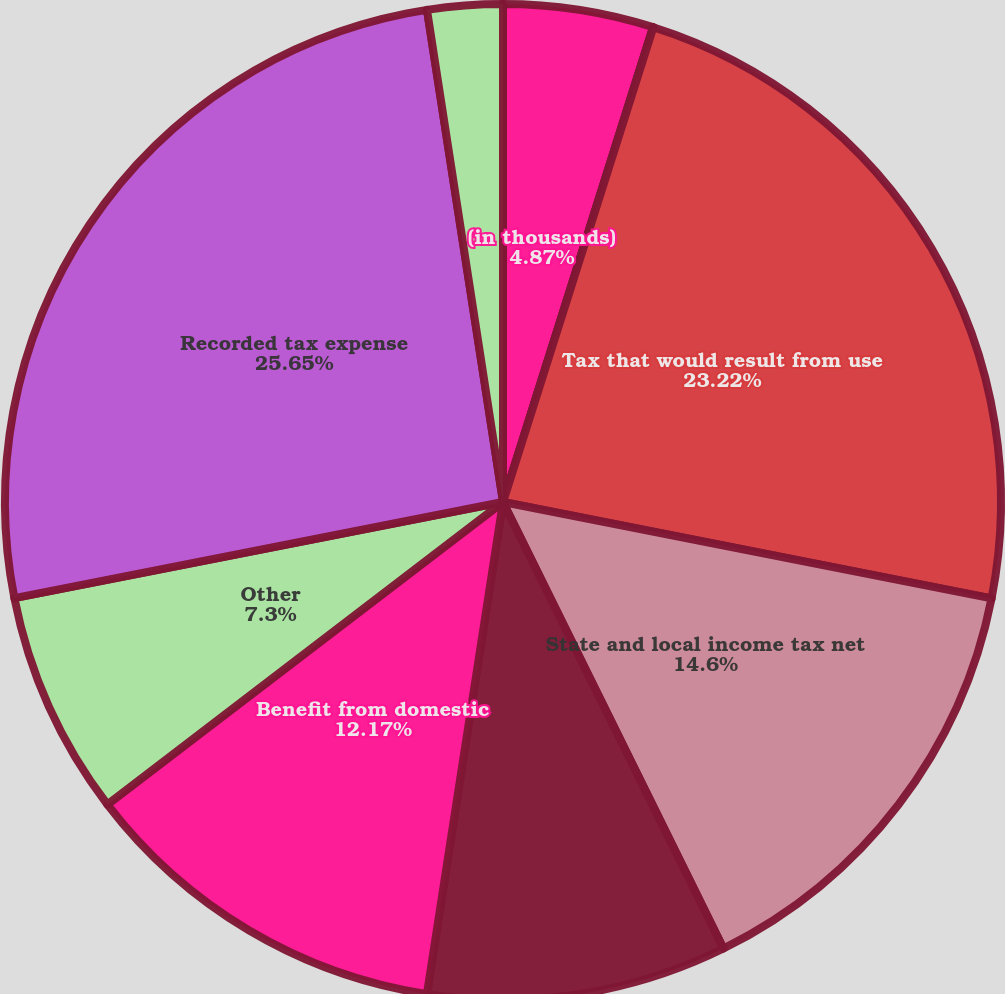<chart> <loc_0><loc_0><loc_500><loc_500><pie_chart><fcel>(in thousands)<fcel>Statutory rate<fcel>Tax that would result from use<fcel>State and local income tax net<fcel>Varying tax rates of foreign<fcel>Benefit from domestic<fcel>Other<fcel>Recorded tax expense<fcel>Effective tax rate<nl><fcel>4.87%<fcel>0.01%<fcel>23.22%<fcel>14.6%<fcel>9.74%<fcel>12.17%<fcel>7.3%<fcel>25.65%<fcel>2.44%<nl></chart> 